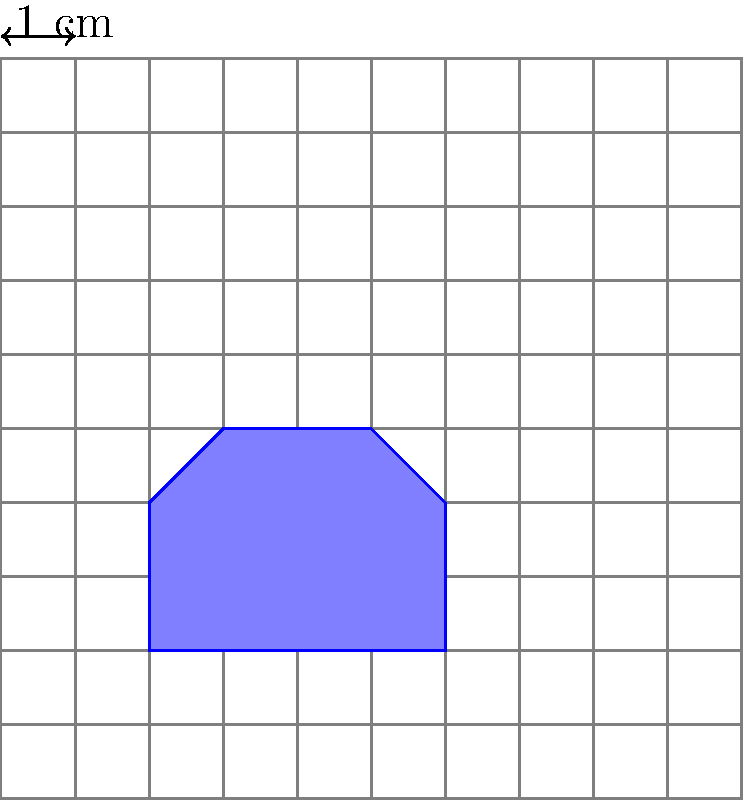As a bakery owner, you've designed a new cookie cutter for your popular "Mom's Park Picnic" collection. The shape is irregular, so you've placed it on a grid where each square represents 1 cm². Using the grid overlay, estimate the area of the cookie cutter to the nearest whole square centimeter. To estimate the area of the irregular cookie cutter shape, we'll count the number of whole squares and partial squares it covers:

1. Count whole squares: There are 8 whole squares completely within the shape.

2. Estimate partial squares:
   - Top: About 1.5 squares
   - Bottom: About 1.5 squares
   - Left side: About 0.5 square
   - Right side: About 0.5 square

3. Sum up the estimates:
   $$\text{Total area} \approx 8 + 1.5 + 1.5 + 0.5 + 0.5 = 12 \text{ cm²}$$

4. Round to the nearest whole square centimeter:
   $$12 \text{ cm²}$$ (already a whole number, so no rounding needed)

Therefore, the estimated area of the cookie cutter is 12 cm².
Answer: 12 cm² 